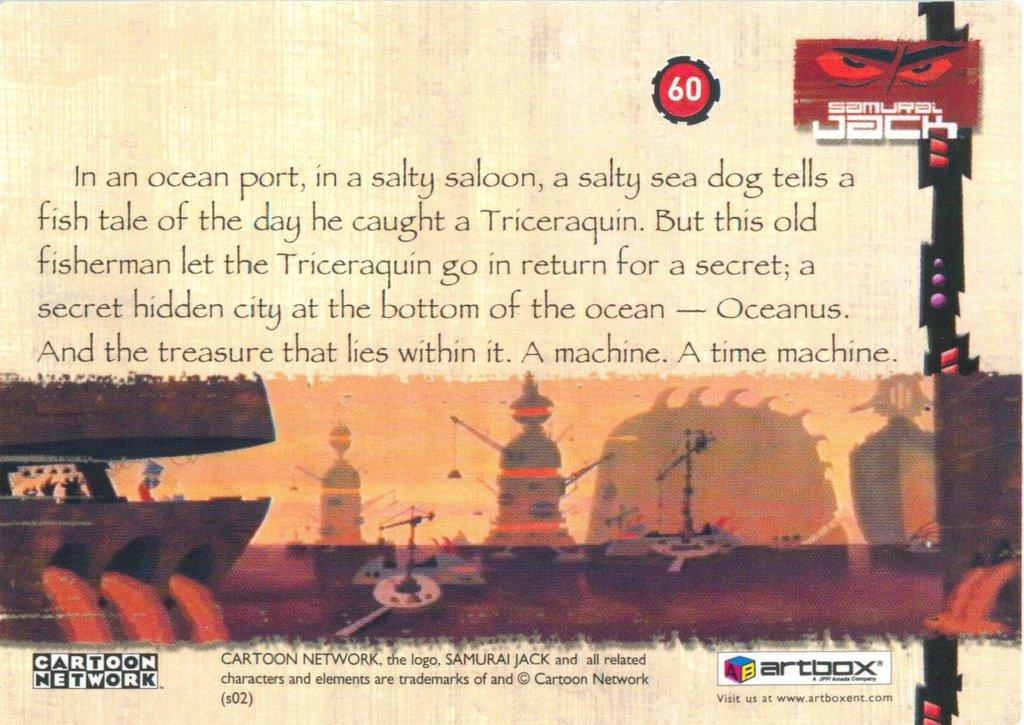What is present on the poster in the image? There is a poster in the image. What can be found on the poster besides images? There is writing and logos on the poster. How many snails can be seen crawling on the face of the person in the image? There is no face or snails present in the image; it only features a poster with writing, logos, and images. 